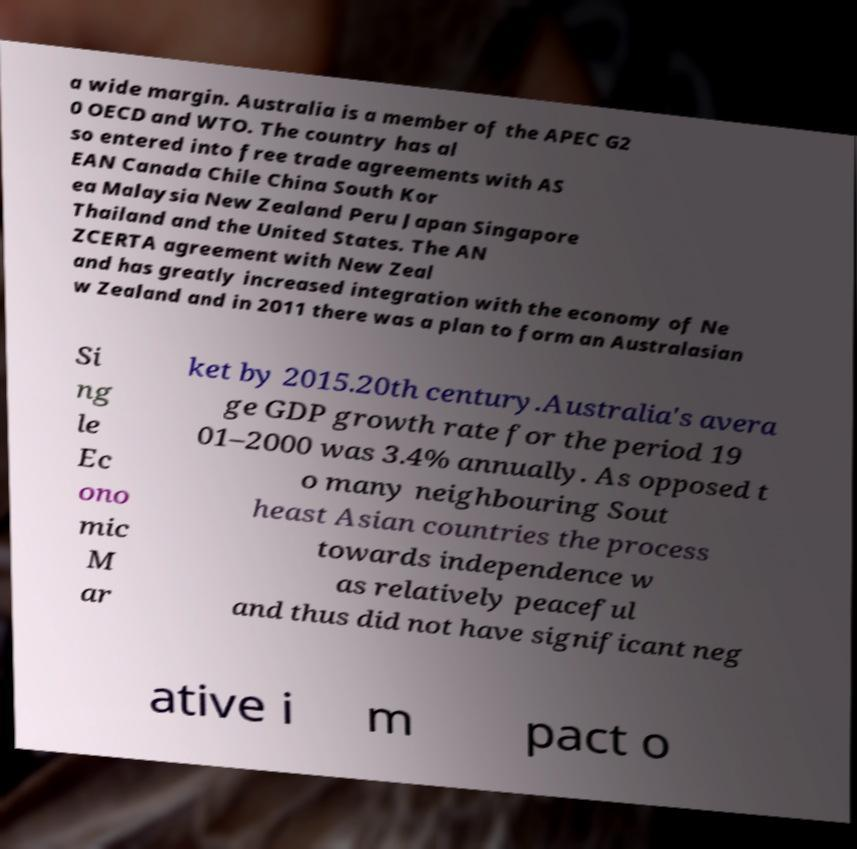There's text embedded in this image that I need extracted. Can you transcribe it verbatim? a wide margin. Australia is a member of the APEC G2 0 OECD and WTO. The country has al so entered into free trade agreements with AS EAN Canada Chile China South Kor ea Malaysia New Zealand Peru Japan Singapore Thailand and the United States. The AN ZCERTA agreement with New Zeal and has greatly increased integration with the economy of Ne w Zealand and in 2011 there was a plan to form an Australasian Si ng le Ec ono mic M ar ket by 2015.20th century.Australia's avera ge GDP growth rate for the period 19 01–2000 was 3.4% annually. As opposed t o many neighbouring Sout heast Asian countries the process towards independence w as relatively peaceful and thus did not have significant neg ative i m pact o 